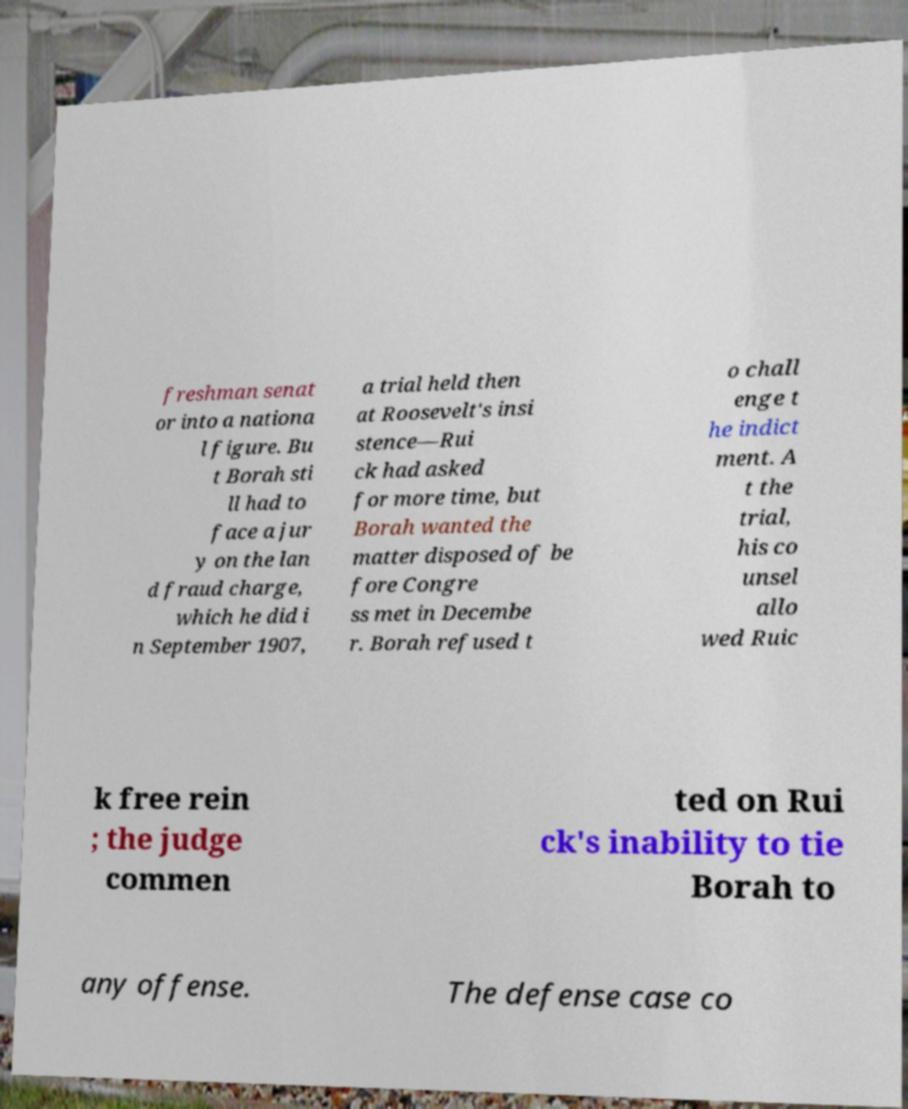What messages or text are displayed in this image? I need them in a readable, typed format. freshman senat or into a nationa l figure. Bu t Borah sti ll had to face a jur y on the lan d fraud charge, which he did i n September 1907, a trial held then at Roosevelt's insi stence—Rui ck had asked for more time, but Borah wanted the matter disposed of be fore Congre ss met in Decembe r. Borah refused t o chall enge t he indict ment. A t the trial, his co unsel allo wed Ruic k free rein ; the judge commen ted on Rui ck's inability to tie Borah to any offense. The defense case co 